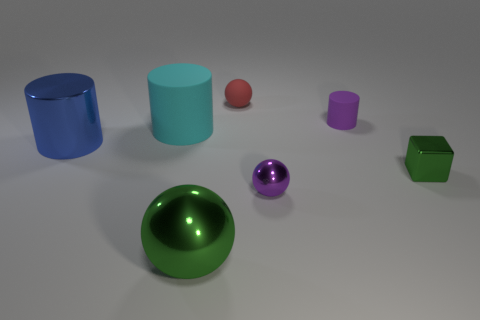Add 1 big shiny cylinders. How many objects exist? 8 Subtract all cubes. How many objects are left? 6 Add 4 large matte cylinders. How many large matte cylinders are left? 5 Add 7 red balls. How many red balls exist? 8 Subtract 1 cyan cylinders. How many objects are left? 6 Subtract all big red metal blocks. Subtract all small matte balls. How many objects are left? 6 